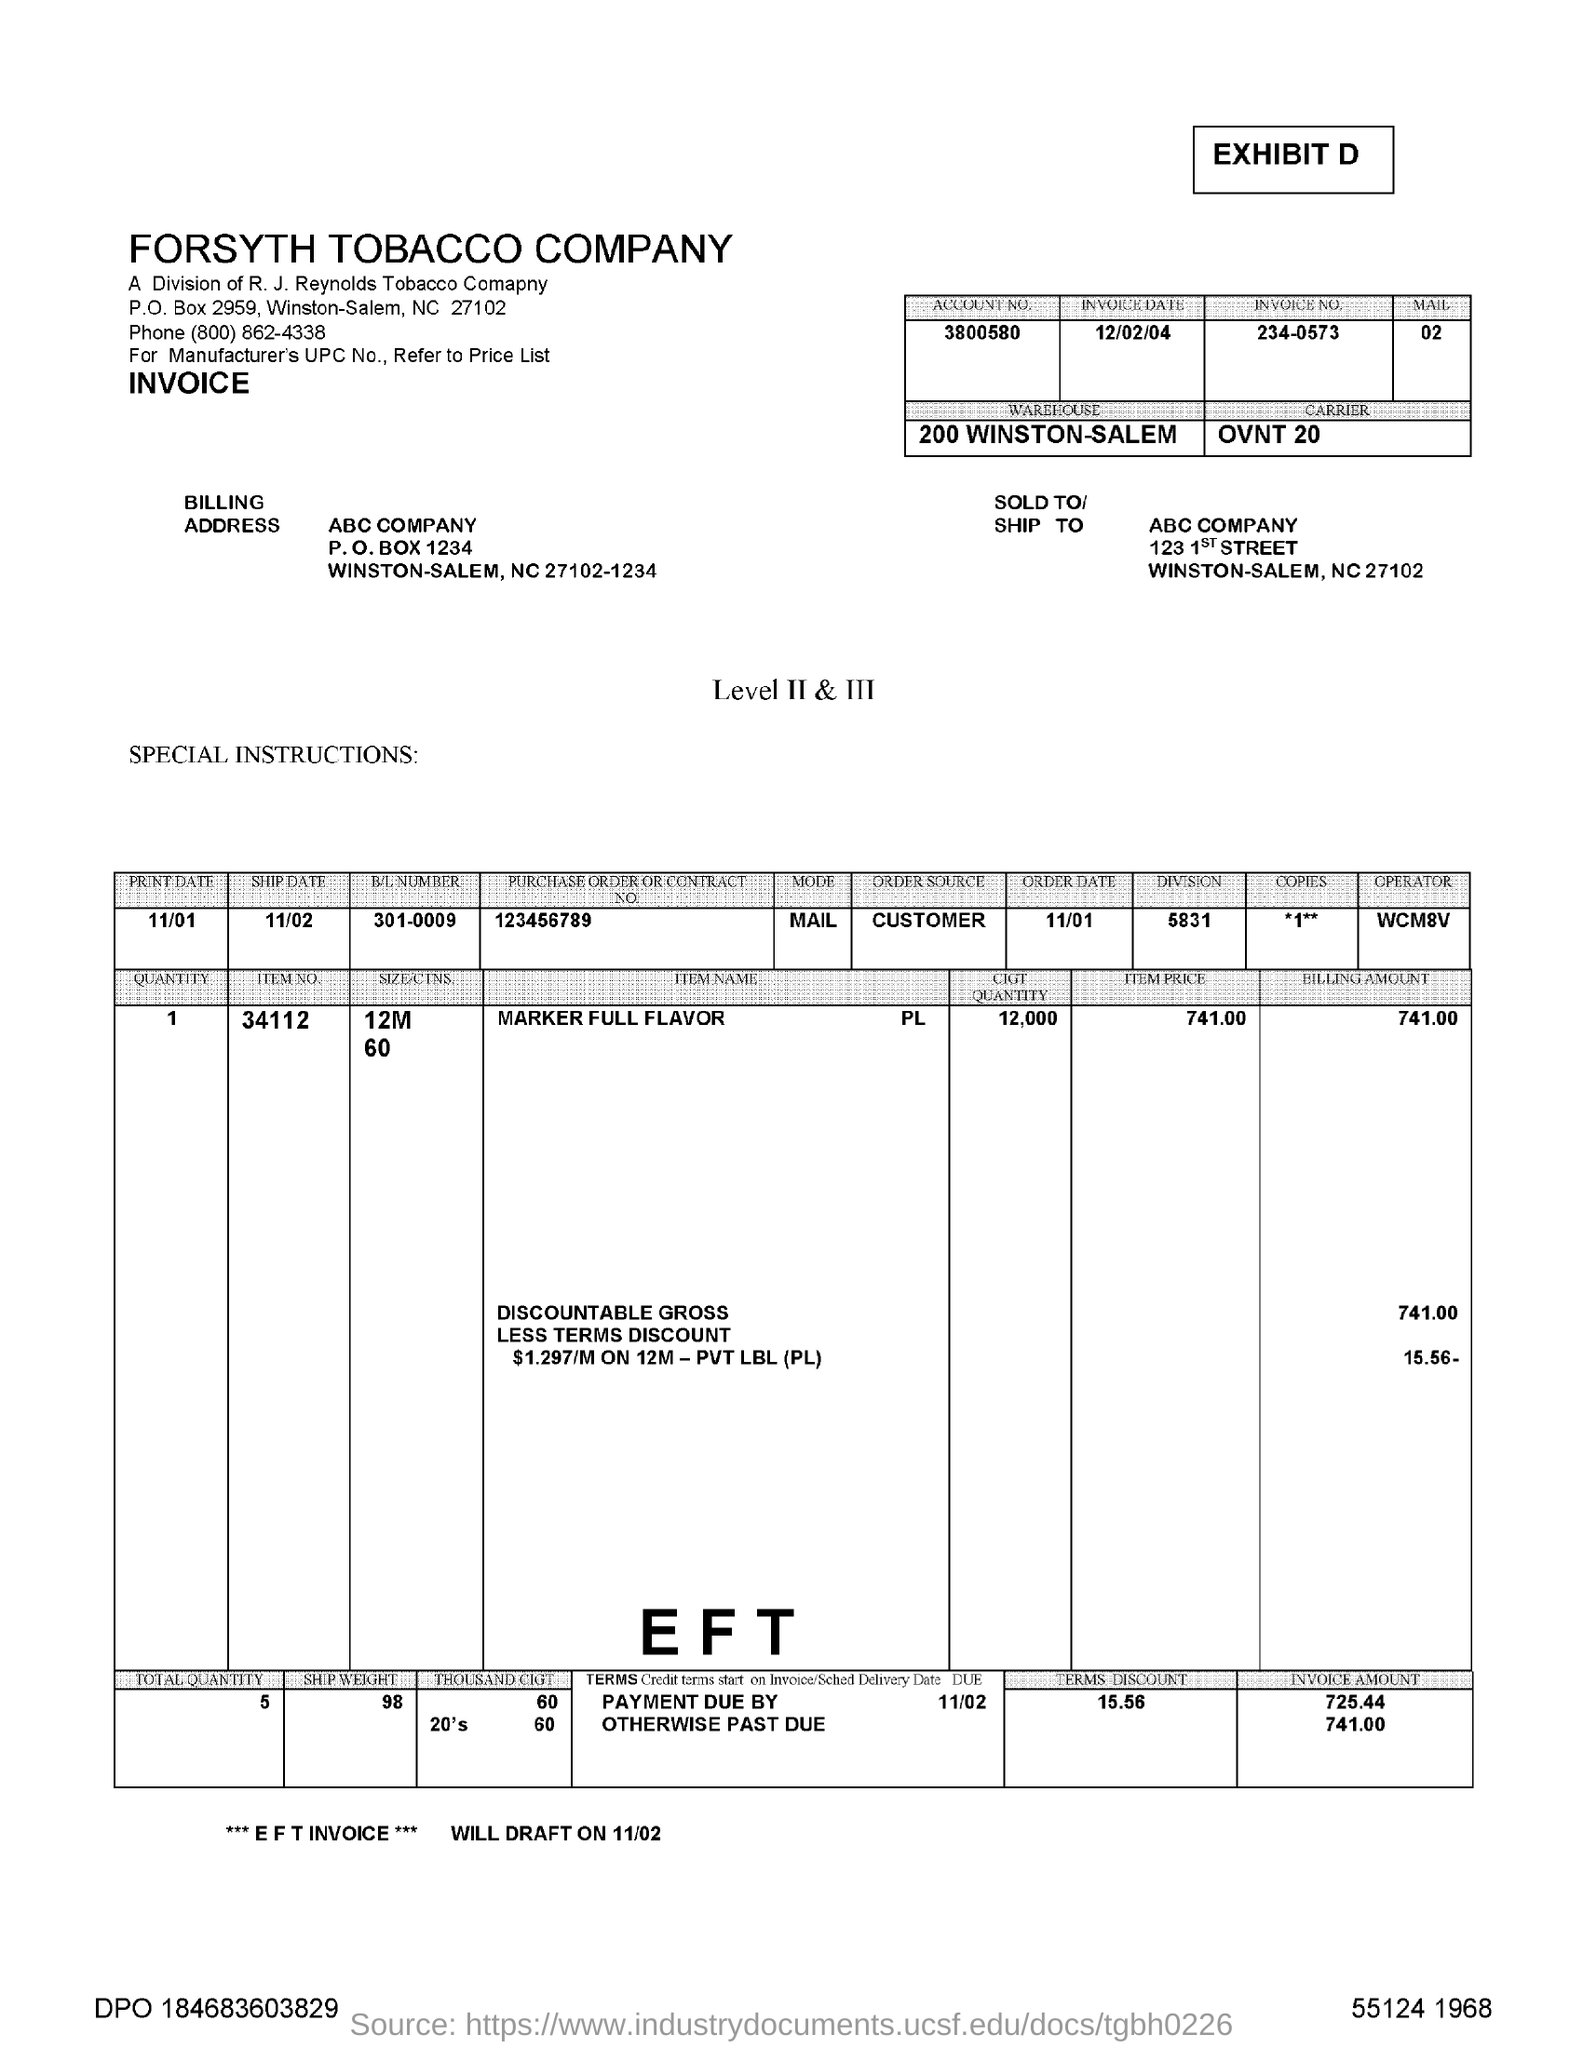What is the Account No given?
Your response must be concise. 3800580. What is the 'INVOICE DATE'?
Give a very brief answer. 12/02/04. Specify the 'INVOICE NO.' ?
Provide a short and direct response. 234-0573. Which 'WAREHOUSE' is mentioned?
Offer a very short reply. 200 WINSTON-SALEM. What is the P.O. Box number in "Billing Address" ?
Offer a terse response. 1234. Which company is specified in 'Billing Address' ?
Offer a terse response. ABC COMPANY. How much is the Invoice Amount on 'Payment Due by' date 11/02 ?
Make the answer very short. 725.44. How much is the 'TERMS DISCOUNT' ?
Provide a succinct answer. 15.56. What is the invoice number given?
Give a very brief answer. 234-0573. What is the 'ITEM NO.' from the table?
Your response must be concise. 34112. 